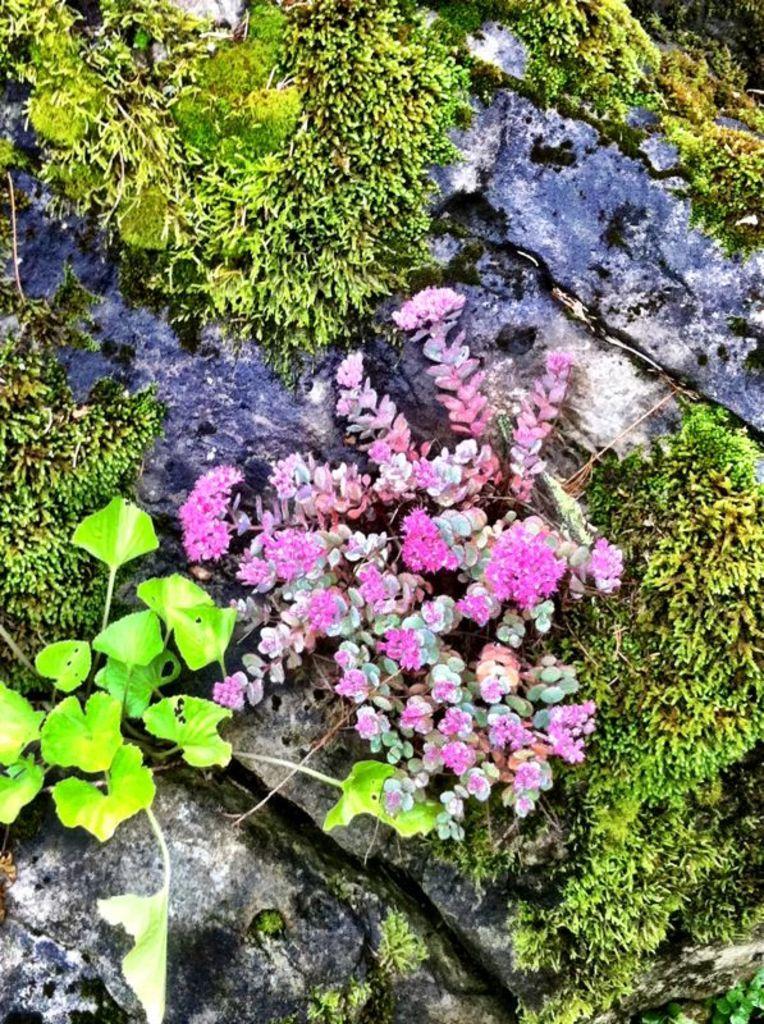In one or two sentences, can you explain what this image depicts? In this image we can see flowers, grass and rocks. 